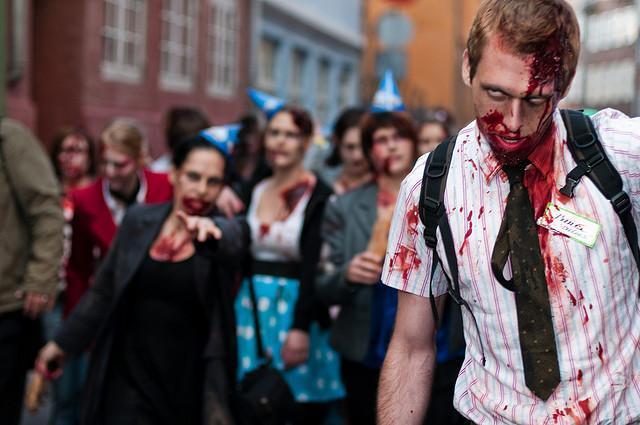How many green ties are there?
Give a very brief answer. 1. How many people are there?
Give a very brief answer. 8. How many train cars have yellow on them?
Give a very brief answer. 0. 